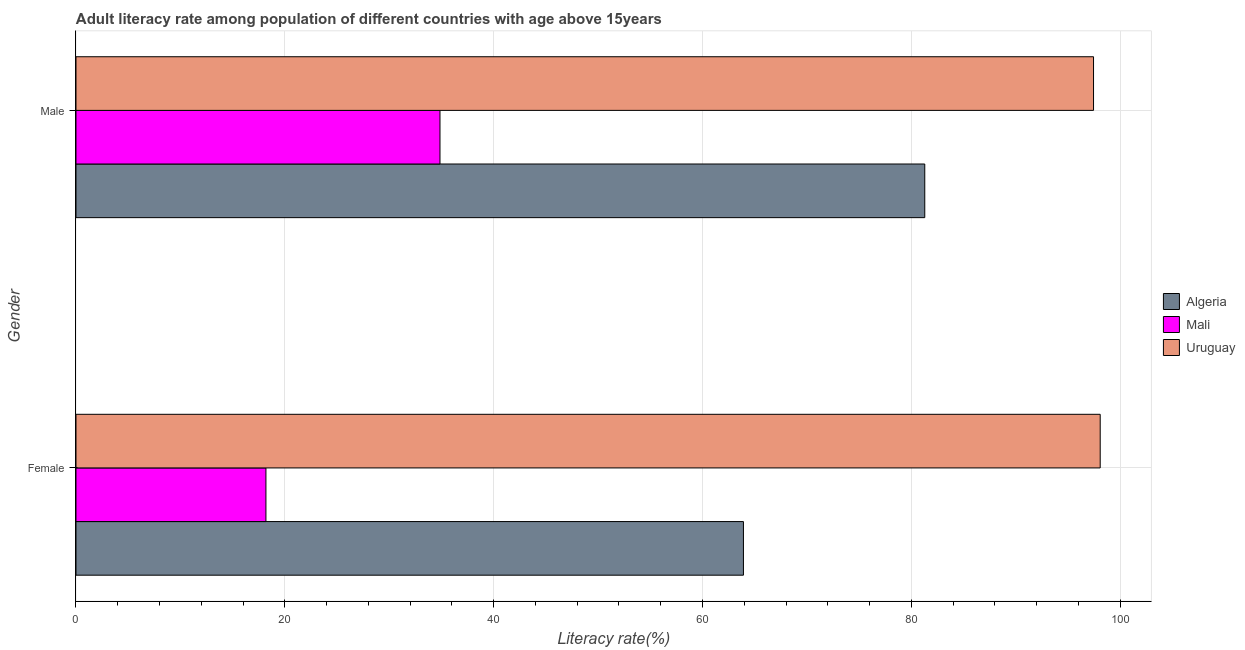Are the number of bars per tick equal to the number of legend labels?
Your answer should be very brief. Yes. What is the label of the 1st group of bars from the top?
Ensure brevity in your answer.  Male. What is the female adult literacy rate in Mali?
Give a very brief answer. 18.19. Across all countries, what is the maximum male adult literacy rate?
Your answer should be compact. 97.44. Across all countries, what is the minimum female adult literacy rate?
Provide a succinct answer. 18.19. In which country was the female adult literacy rate maximum?
Provide a succinct answer. Uruguay. In which country was the male adult literacy rate minimum?
Your answer should be compact. Mali. What is the total male adult literacy rate in the graph?
Ensure brevity in your answer.  213.59. What is the difference between the male adult literacy rate in Algeria and that in Mali?
Offer a very short reply. 46.43. What is the difference between the male adult literacy rate in Mali and the female adult literacy rate in Uruguay?
Make the answer very short. -63.23. What is the average male adult literacy rate per country?
Your answer should be very brief. 71.2. What is the difference between the female adult literacy rate and male adult literacy rate in Uruguay?
Keep it short and to the point. 0.64. In how many countries, is the female adult literacy rate greater than 68 %?
Provide a succinct answer. 1. What is the ratio of the female adult literacy rate in Mali to that in Algeria?
Offer a very short reply. 0.28. Is the female adult literacy rate in Uruguay less than that in Algeria?
Your response must be concise. No. What does the 2nd bar from the top in Male represents?
Offer a very short reply. Mali. What does the 2nd bar from the bottom in Female represents?
Offer a terse response. Mali. Are all the bars in the graph horizontal?
Give a very brief answer. Yes. Does the graph contain grids?
Your response must be concise. Yes. What is the title of the graph?
Your response must be concise. Adult literacy rate among population of different countries with age above 15years. Does "Dominican Republic" appear as one of the legend labels in the graph?
Offer a very short reply. No. What is the label or title of the X-axis?
Make the answer very short. Literacy rate(%). What is the Literacy rate(%) of Algeria in Female?
Your answer should be compact. 63.92. What is the Literacy rate(%) in Mali in Female?
Make the answer very short. 18.19. What is the Literacy rate(%) in Uruguay in Female?
Ensure brevity in your answer.  98.08. What is the Literacy rate(%) in Algeria in Male?
Your answer should be compact. 81.28. What is the Literacy rate(%) in Mali in Male?
Your response must be concise. 34.86. What is the Literacy rate(%) in Uruguay in Male?
Keep it short and to the point. 97.44. Across all Gender, what is the maximum Literacy rate(%) of Algeria?
Keep it short and to the point. 81.28. Across all Gender, what is the maximum Literacy rate(%) in Mali?
Offer a terse response. 34.86. Across all Gender, what is the maximum Literacy rate(%) in Uruguay?
Your answer should be compact. 98.08. Across all Gender, what is the minimum Literacy rate(%) of Algeria?
Your answer should be very brief. 63.92. Across all Gender, what is the minimum Literacy rate(%) in Mali?
Give a very brief answer. 18.19. Across all Gender, what is the minimum Literacy rate(%) in Uruguay?
Your answer should be compact. 97.44. What is the total Literacy rate(%) in Algeria in the graph?
Your response must be concise. 145.2. What is the total Literacy rate(%) in Mali in the graph?
Your answer should be very brief. 53.05. What is the total Literacy rate(%) of Uruguay in the graph?
Your answer should be very brief. 195.53. What is the difference between the Literacy rate(%) in Algeria in Female and that in Male?
Offer a very short reply. -17.37. What is the difference between the Literacy rate(%) of Mali in Female and that in Male?
Provide a succinct answer. -16.67. What is the difference between the Literacy rate(%) of Uruguay in Female and that in Male?
Provide a succinct answer. 0.64. What is the difference between the Literacy rate(%) in Algeria in Female and the Literacy rate(%) in Mali in Male?
Your response must be concise. 29.06. What is the difference between the Literacy rate(%) of Algeria in Female and the Literacy rate(%) of Uruguay in Male?
Your answer should be very brief. -33.53. What is the difference between the Literacy rate(%) in Mali in Female and the Literacy rate(%) in Uruguay in Male?
Your answer should be very brief. -79.25. What is the average Literacy rate(%) of Algeria per Gender?
Offer a terse response. 72.6. What is the average Literacy rate(%) of Mali per Gender?
Your answer should be very brief. 26.52. What is the average Literacy rate(%) of Uruguay per Gender?
Your answer should be compact. 97.76. What is the difference between the Literacy rate(%) in Algeria and Literacy rate(%) in Mali in Female?
Offer a very short reply. 45.73. What is the difference between the Literacy rate(%) in Algeria and Literacy rate(%) in Uruguay in Female?
Your response must be concise. -34.17. What is the difference between the Literacy rate(%) of Mali and Literacy rate(%) of Uruguay in Female?
Provide a short and direct response. -79.89. What is the difference between the Literacy rate(%) in Algeria and Literacy rate(%) in Mali in Male?
Ensure brevity in your answer.  46.43. What is the difference between the Literacy rate(%) in Algeria and Literacy rate(%) in Uruguay in Male?
Your answer should be compact. -16.16. What is the difference between the Literacy rate(%) of Mali and Literacy rate(%) of Uruguay in Male?
Give a very brief answer. -62.59. What is the ratio of the Literacy rate(%) of Algeria in Female to that in Male?
Make the answer very short. 0.79. What is the ratio of the Literacy rate(%) of Mali in Female to that in Male?
Offer a very short reply. 0.52. What is the ratio of the Literacy rate(%) of Uruguay in Female to that in Male?
Your answer should be very brief. 1.01. What is the difference between the highest and the second highest Literacy rate(%) in Algeria?
Keep it short and to the point. 17.37. What is the difference between the highest and the second highest Literacy rate(%) in Mali?
Provide a short and direct response. 16.67. What is the difference between the highest and the second highest Literacy rate(%) in Uruguay?
Your answer should be compact. 0.64. What is the difference between the highest and the lowest Literacy rate(%) of Algeria?
Provide a short and direct response. 17.37. What is the difference between the highest and the lowest Literacy rate(%) of Mali?
Offer a very short reply. 16.67. What is the difference between the highest and the lowest Literacy rate(%) in Uruguay?
Your response must be concise. 0.64. 